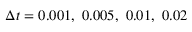Convert formula to latex. <formula><loc_0><loc_0><loc_500><loc_500>\Delta t = 0 . 0 0 1 , \ 0 . 0 0 5 , \ 0 . 0 1 , \ 0 . 0 2</formula> 